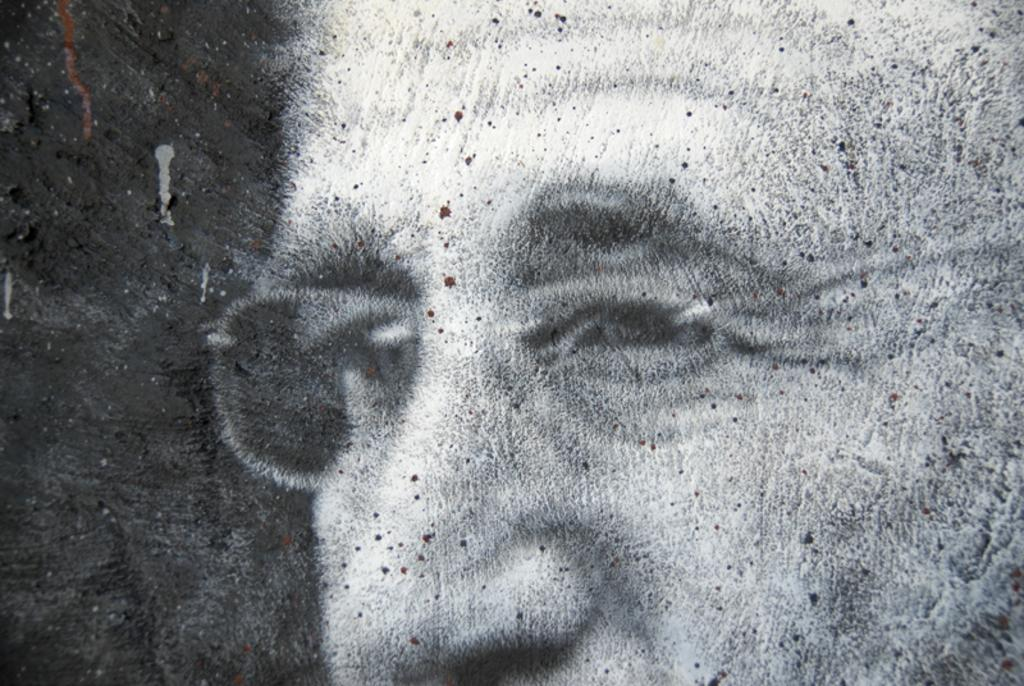What can be observed about the clarity of the image? The image is blurred. What accessory is the person in the image wearing? The person in the image is wearing spectacles. What color scheme is used in the image? The image is black and white. What can be seen on the person's face in the image? There are dots on the person's face in the image. What type of twig is the person holding in the image? There is no twig present in the image. How does the person in the image feel about the situation? The image does not convey any emotions or feelings, so it is impossible to determine how the person feels. 